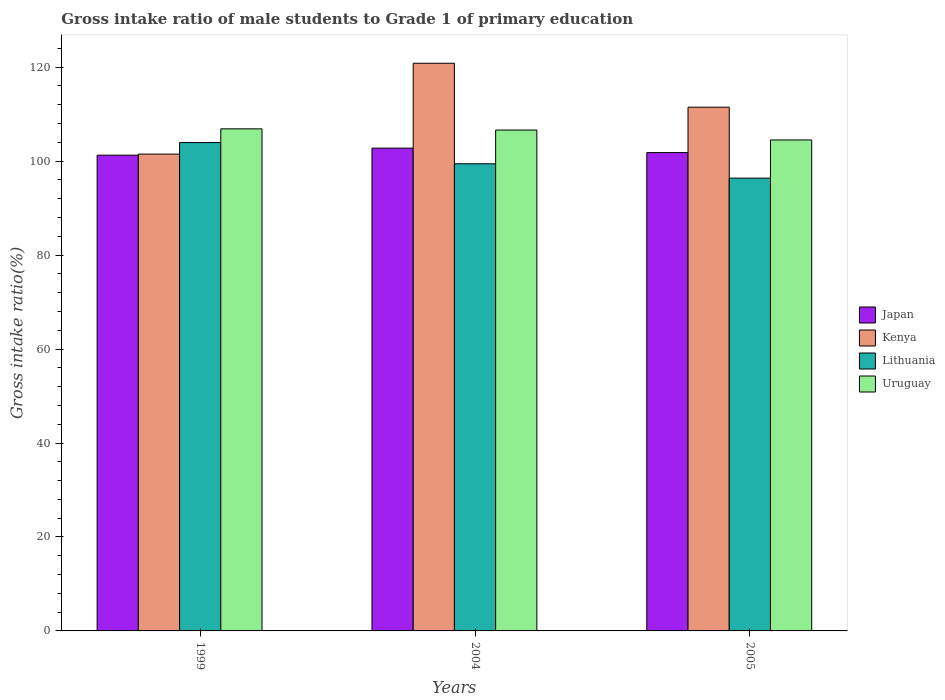How many groups of bars are there?
Ensure brevity in your answer.  3. In how many cases, is the number of bars for a given year not equal to the number of legend labels?
Make the answer very short. 0. What is the gross intake ratio in Lithuania in 2005?
Your response must be concise. 96.38. Across all years, what is the maximum gross intake ratio in Kenya?
Ensure brevity in your answer.  120.83. Across all years, what is the minimum gross intake ratio in Japan?
Provide a short and direct response. 101.26. In which year was the gross intake ratio in Japan minimum?
Offer a very short reply. 1999. What is the total gross intake ratio in Uruguay in the graph?
Provide a short and direct response. 317.99. What is the difference between the gross intake ratio in Uruguay in 2004 and that in 2005?
Your response must be concise. 2.11. What is the difference between the gross intake ratio in Japan in 1999 and the gross intake ratio in Kenya in 2004?
Keep it short and to the point. -19.57. What is the average gross intake ratio in Uruguay per year?
Provide a short and direct response. 106. In the year 1999, what is the difference between the gross intake ratio in Kenya and gross intake ratio in Lithuania?
Offer a very short reply. -2.46. What is the ratio of the gross intake ratio in Japan in 2004 to that in 2005?
Your answer should be very brief. 1.01. What is the difference between the highest and the second highest gross intake ratio in Kenya?
Ensure brevity in your answer.  9.35. What is the difference between the highest and the lowest gross intake ratio in Uruguay?
Provide a succinct answer. 2.36. In how many years, is the gross intake ratio in Kenya greater than the average gross intake ratio in Kenya taken over all years?
Provide a short and direct response. 2. Is it the case that in every year, the sum of the gross intake ratio in Lithuania and gross intake ratio in Uruguay is greater than the sum of gross intake ratio in Kenya and gross intake ratio in Japan?
Your response must be concise. No. What does the 2nd bar from the left in 2005 represents?
Your response must be concise. Kenya. What does the 2nd bar from the right in 2004 represents?
Make the answer very short. Lithuania. Are the values on the major ticks of Y-axis written in scientific E-notation?
Your answer should be compact. No. How are the legend labels stacked?
Give a very brief answer. Vertical. What is the title of the graph?
Make the answer very short. Gross intake ratio of male students to Grade 1 of primary education. Does "Italy" appear as one of the legend labels in the graph?
Your response must be concise. No. What is the label or title of the X-axis?
Your response must be concise. Years. What is the label or title of the Y-axis?
Give a very brief answer. Gross intake ratio(%). What is the Gross intake ratio(%) in Japan in 1999?
Make the answer very short. 101.26. What is the Gross intake ratio(%) of Kenya in 1999?
Your answer should be very brief. 101.49. What is the Gross intake ratio(%) in Lithuania in 1999?
Offer a very short reply. 103.95. What is the Gross intake ratio(%) of Uruguay in 1999?
Keep it short and to the point. 106.87. What is the Gross intake ratio(%) in Japan in 2004?
Provide a succinct answer. 102.77. What is the Gross intake ratio(%) in Kenya in 2004?
Your answer should be very brief. 120.83. What is the Gross intake ratio(%) of Lithuania in 2004?
Provide a succinct answer. 99.43. What is the Gross intake ratio(%) of Uruguay in 2004?
Provide a short and direct response. 106.62. What is the Gross intake ratio(%) of Japan in 2005?
Provide a short and direct response. 101.82. What is the Gross intake ratio(%) of Kenya in 2005?
Give a very brief answer. 111.48. What is the Gross intake ratio(%) in Lithuania in 2005?
Provide a short and direct response. 96.38. What is the Gross intake ratio(%) of Uruguay in 2005?
Ensure brevity in your answer.  104.5. Across all years, what is the maximum Gross intake ratio(%) in Japan?
Your answer should be very brief. 102.77. Across all years, what is the maximum Gross intake ratio(%) in Kenya?
Ensure brevity in your answer.  120.83. Across all years, what is the maximum Gross intake ratio(%) of Lithuania?
Make the answer very short. 103.95. Across all years, what is the maximum Gross intake ratio(%) of Uruguay?
Make the answer very short. 106.87. Across all years, what is the minimum Gross intake ratio(%) of Japan?
Provide a short and direct response. 101.26. Across all years, what is the minimum Gross intake ratio(%) in Kenya?
Your answer should be very brief. 101.49. Across all years, what is the minimum Gross intake ratio(%) of Lithuania?
Provide a short and direct response. 96.38. Across all years, what is the minimum Gross intake ratio(%) of Uruguay?
Provide a short and direct response. 104.5. What is the total Gross intake ratio(%) of Japan in the graph?
Offer a very short reply. 305.85. What is the total Gross intake ratio(%) in Kenya in the graph?
Offer a very short reply. 333.81. What is the total Gross intake ratio(%) of Lithuania in the graph?
Offer a terse response. 299.77. What is the total Gross intake ratio(%) in Uruguay in the graph?
Your answer should be compact. 317.99. What is the difference between the Gross intake ratio(%) of Japan in 1999 and that in 2004?
Give a very brief answer. -1.5. What is the difference between the Gross intake ratio(%) in Kenya in 1999 and that in 2004?
Offer a very short reply. -19.34. What is the difference between the Gross intake ratio(%) of Lithuania in 1999 and that in 2004?
Keep it short and to the point. 4.52. What is the difference between the Gross intake ratio(%) of Uruguay in 1999 and that in 2004?
Ensure brevity in your answer.  0.25. What is the difference between the Gross intake ratio(%) of Japan in 1999 and that in 2005?
Offer a terse response. -0.55. What is the difference between the Gross intake ratio(%) of Kenya in 1999 and that in 2005?
Your answer should be very brief. -9.98. What is the difference between the Gross intake ratio(%) of Lithuania in 1999 and that in 2005?
Your response must be concise. 7.57. What is the difference between the Gross intake ratio(%) in Uruguay in 1999 and that in 2005?
Provide a short and direct response. 2.37. What is the difference between the Gross intake ratio(%) of Japan in 2004 and that in 2005?
Provide a succinct answer. 0.95. What is the difference between the Gross intake ratio(%) of Kenya in 2004 and that in 2005?
Your answer should be very brief. 9.35. What is the difference between the Gross intake ratio(%) of Lithuania in 2004 and that in 2005?
Ensure brevity in your answer.  3.05. What is the difference between the Gross intake ratio(%) of Uruguay in 2004 and that in 2005?
Offer a very short reply. 2.11. What is the difference between the Gross intake ratio(%) in Japan in 1999 and the Gross intake ratio(%) in Kenya in 2004?
Your response must be concise. -19.57. What is the difference between the Gross intake ratio(%) of Japan in 1999 and the Gross intake ratio(%) of Lithuania in 2004?
Provide a succinct answer. 1.83. What is the difference between the Gross intake ratio(%) in Japan in 1999 and the Gross intake ratio(%) in Uruguay in 2004?
Offer a terse response. -5.35. What is the difference between the Gross intake ratio(%) in Kenya in 1999 and the Gross intake ratio(%) in Lithuania in 2004?
Make the answer very short. 2.06. What is the difference between the Gross intake ratio(%) of Kenya in 1999 and the Gross intake ratio(%) of Uruguay in 2004?
Offer a very short reply. -5.12. What is the difference between the Gross intake ratio(%) of Lithuania in 1999 and the Gross intake ratio(%) of Uruguay in 2004?
Your answer should be very brief. -2.67. What is the difference between the Gross intake ratio(%) of Japan in 1999 and the Gross intake ratio(%) of Kenya in 2005?
Your answer should be very brief. -10.21. What is the difference between the Gross intake ratio(%) of Japan in 1999 and the Gross intake ratio(%) of Lithuania in 2005?
Offer a terse response. 4.88. What is the difference between the Gross intake ratio(%) in Japan in 1999 and the Gross intake ratio(%) in Uruguay in 2005?
Your answer should be very brief. -3.24. What is the difference between the Gross intake ratio(%) in Kenya in 1999 and the Gross intake ratio(%) in Lithuania in 2005?
Your answer should be compact. 5.11. What is the difference between the Gross intake ratio(%) in Kenya in 1999 and the Gross intake ratio(%) in Uruguay in 2005?
Ensure brevity in your answer.  -3.01. What is the difference between the Gross intake ratio(%) of Lithuania in 1999 and the Gross intake ratio(%) of Uruguay in 2005?
Give a very brief answer. -0.55. What is the difference between the Gross intake ratio(%) in Japan in 2004 and the Gross intake ratio(%) in Kenya in 2005?
Offer a terse response. -8.71. What is the difference between the Gross intake ratio(%) in Japan in 2004 and the Gross intake ratio(%) in Lithuania in 2005?
Give a very brief answer. 6.39. What is the difference between the Gross intake ratio(%) in Japan in 2004 and the Gross intake ratio(%) in Uruguay in 2005?
Your answer should be compact. -1.74. What is the difference between the Gross intake ratio(%) of Kenya in 2004 and the Gross intake ratio(%) of Lithuania in 2005?
Your answer should be compact. 24.45. What is the difference between the Gross intake ratio(%) in Kenya in 2004 and the Gross intake ratio(%) in Uruguay in 2005?
Your response must be concise. 16.33. What is the difference between the Gross intake ratio(%) in Lithuania in 2004 and the Gross intake ratio(%) in Uruguay in 2005?
Your response must be concise. -5.07. What is the average Gross intake ratio(%) in Japan per year?
Offer a terse response. 101.95. What is the average Gross intake ratio(%) of Kenya per year?
Give a very brief answer. 111.27. What is the average Gross intake ratio(%) in Lithuania per year?
Provide a short and direct response. 99.92. What is the average Gross intake ratio(%) of Uruguay per year?
Provide a succinct answer. 106. In the year 1999, what is the difference between the Gross intake ratio(%) in Japan and Gross intake ratio(%) in Kenya?
Offer a terse response. -0.23. In the year 1999, what is the difference between the Gross intake ratio(%) of Japan and Gross intake ratio(%) of Lithuania?
Keep it short and to the point. -2.69. In the year 1999, what is the difference between the Gross intake ratio(%) of Japan and Gross intake ratio(%) of Uruguay?
Provide a succinct answer. -5.6. In the year 1999, what is the difference between the Gross intake ratio(%) of Kenya and Gross intake ratio(%) of Lithuania?
Provide a succinct answer. -2.46. In the year 1999, what is the difference between the Gross intake ratio(%) of Kenya and Gross intake ratio(%) of Uruguay?
Provide a succinct answer. -5.38. In the year 1999, what is the difference between the Gross intake ratio(%) of Lithuania and Gross intake ratio(%) of Uruguay?
Provide a short and direct response. -2.92. In the year 2004, what is the difference between the Gross intake ratio(%) of Japan and Gross intake ratio(%) of Kenya?
Your answer should be very brief. -18.06. In the year 2004, what is the difference between the Gross intake ratio(%) in Japan and Gross intake ratio(%) in Lithuania?
Give a very brief answer. 3.33. In the year 2004, what is the difference between the Gross intake ratio(%) in Japan and Gross intake ratio(%) in Uruguay?
Provide a succinct answer. -3.85. In the year 2004, what is the difference between the Gross intake ratio(%) in Kenya and Gross intake ratio(%) in Lithuania?
Ensure brevity in your answer.  21.4. In the year 2004, what is the difference between the Gross intake ratio(%) in Kenya and Gross intake ratio(%) in Uruguay?
Offer a terse response. 14.21. In the year 2004, what is the difference between the Gross intake ratio(%) in Lithuania and Gross intake ratio(%) in Uruguay?
Provide a short and direct response. -7.18. In the year 2005, what is the difference between the Gross intake ratio(%) of Japan and Gross intake ratio(%) of Kenya?
Give a very brief answer. -9.66. In the year 2005, what is the difference between the Gross intake ratio(%) of Japan and Gross intake ratio(%) of Lithuania?
Your answer should be compact. 5.43. In the year 2005, what is the difference between the Gross intake ratio(%) in Japan and Gross intake ratio(%) in Uruguay?
Offer a terse response. -2.69. In the year 2005, what is the difference between the Gross intake ratio(%) in Kenya and Gross intake ratio(%) in Lithuania?
Your response must be concise. 15.1. In the year 2005, what is the difference between the Gross intake ratio(%) of Kenya and Gross intake ratio(%) of Uruguay?
Your answer should be compact. 6.97. In the year 2005, what is the difference between the Gross intake ratio(%) in Lithuania and Gross intake ratio(%) in Uruguay?
Provide a short and direct response. -8.12. What is the ratio of the Gross intake ratio(%) of Japan in 1999 to that in 2004?
Your answer should be very brief. 0.99. What is the ratio of the Gross intake ratio(%) in Kenya in 1999 to that in 2004?
Your answer should be compact. 0.84. What is the ratio of the Gross intake ratio(%) in Lithuania in 1999 to that in 2004?
Offer a very short reply. 1.05. What is the ratio of the Gross intake ratio(%) in Uruguay in 1999 to that in 2004?
Keep it short and to the point. 1. What is the ratio of the Gross intake ratio(%) in Japan in 1999 to that in 2005?
Your answer should be very brief. 0.99. What is the ratio of the Gross intake ratio(%) of Kenya in 1999 to that in 2005?
Provide a short and direct response. 0.91. What is the ratio of the Gross intake ratio(%) in Lithuania in 1999 to that in 2005?
Your answer should be compact. 1.08. What is the ratio of the Gross intake ratio(%) of Uruguay in 1999 to that in 2005?
Provide a succinct answer. 1.02. What is the ratio of the Gross intake ratio(%) of Japan in 2004 to that in 2005?
Your answer should be compact. 1.01. What is the ratio of the Gross intake ratio(%) in Kenya in 2004 to that in 2005?
Provide a short and direct response. 1.08. What is the ratio of the Gross intake ratio(%) in Lithuania in 2004 to that in 2005?
Offer a terse response. 1.03. What is the ratio of the Gross intake ratio(%) in Uruguay in 2004 to that in 2005?
Offer a terse response. 1.02. What is the difference between the highest and the second highest Gross intake ratio(%) in Japan?
Your answer should be very brief. 0.95. What is the difference between the highest and the second highest Gross intake ratio(%) in Kenya?
Make the answer very short. 9.35. What is the difference between the highest and the second highest Gross intake ratio(%) in Lithuania?
Your response must be concise. 4.52. What is the difference between the highest and the second highest Gross intake ratio(%) in Uruguay?
Provide a succinct answer. 0.25. What is the difference between the highest and the lowest Gross intake ratio(%) of Japan?
Offer a very short reply. 1.5. What is the difference between the highest and the lowest Gross intake ratio(%) of Kenya?
Offer a terse response. 19.34. What is the difference between the highest and the lowest Gross intake ratio(%) in Lithuania?
Give a very brief answer. 7.57. What is the difference between the highest and the lowest Gross intake ratio(%) of Uruguay?
Offer a terse response. 2.37. 